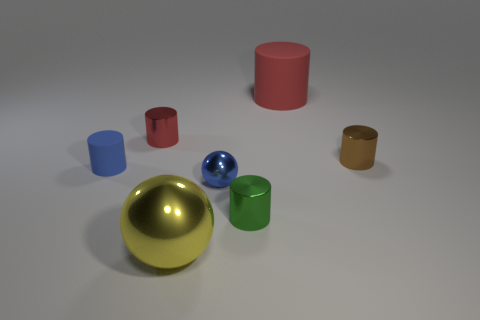How many objects are brown things or tiny gray metallic things?
Give a very brief answer. 1. The red cylinder left of the small shiny sphere on the left side of the large red matte object is made of what material?
Give a very brief answer. Metal. Is there a big yellow cylinder made of the same material as the big red object?
Give a very brief answer. No. What shape is the object that is on the right side of the matte cylinder that is to the right of the sphere in front of the tiny ball?
Your response must be concise. Cylinder. What is the large cylinder made of?
Make the answer very short. Rubber. There is a large object that is made of the same material as the tiny sphere; what is its color?
Make the answer very short. Yellow. Is there a yellow metallic thing on the left side of the small metal thing to the left of the small metal sphere?
Give a very brief answer. No. How many other objects are the same shape as the red rubber thing?
Ensure brevity in your answer.  4. There is a small metal thing to the left of the large yellow thing; is it the same shape as the blue thing that is to the left of the yellow metal sphere?
Your answer should be very brief. Yes. There is a cylinder in front of the matte object on the left side of the large cylinder; what number of small brown things are in front of it?
Ensure brevity in your answer.  0. 